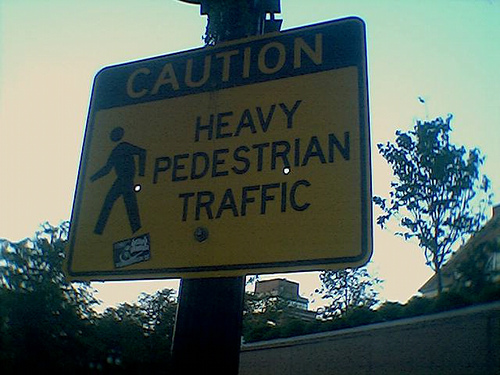Are there any distinguishing features or landmarks in the image that can tell us about the location? The image primarily shows the caution sign itself and only a limited view of the surroundings, including a tree and a part of the building behind. There are no clear landmarks or distinguishing features that would give away a specific location. The setting is not very detailed, making it hard to pinpoint where the sign is placed geographically. 